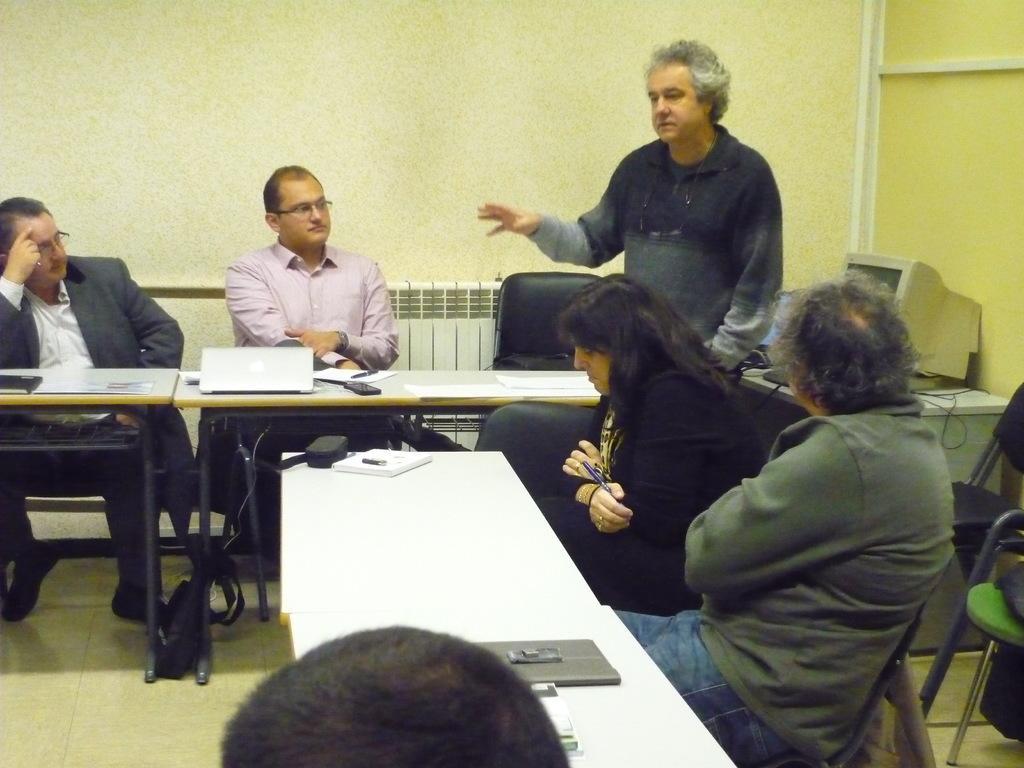Could you give a brief overview of what you see in this image? A man is standing and speaking. There are four other people sitting and listening to him. They are sitting at tables. There is laptop on the table and a desktop in the background. 